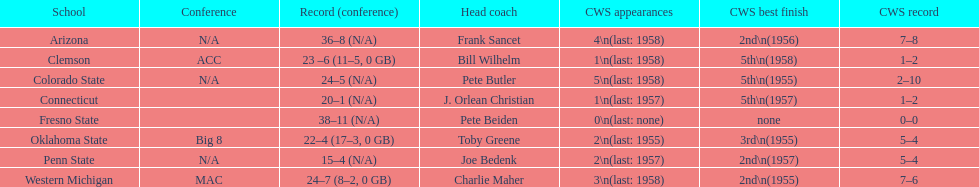List the schools that came in last place in the cws best finish. Clemson, Colorado State, Connecticut. 